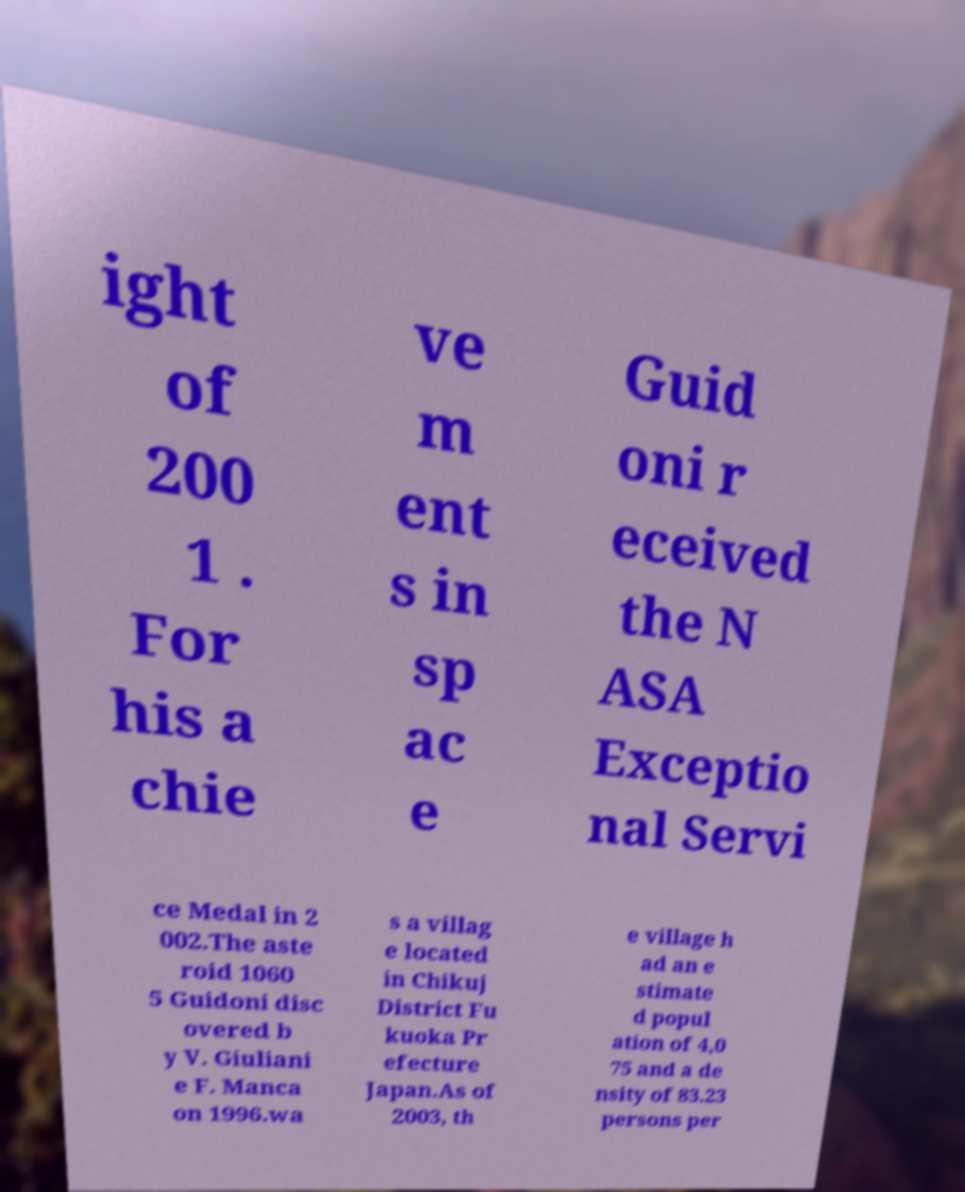Can you read and provide the text displayed in the image?This photo seems to have some interesting text. Can you extract and type it out for me? ight of 200 1 . For his a chie ve m ent s in sp ac e Guid oni r eceived the N ASA Exceptio nal Servi ce Medal in 2 002.The aste roid 1060 5 Guidoni disc overed b y V. Giuliani e F. Manca on 1996.wa s a villag e located in Chikuj District Fu kuoka Pr efecture Japan.As of 2003, th e village h ad an e stimate d popul ation of 4,0 75 and a de nsity of 83.23 persons per 